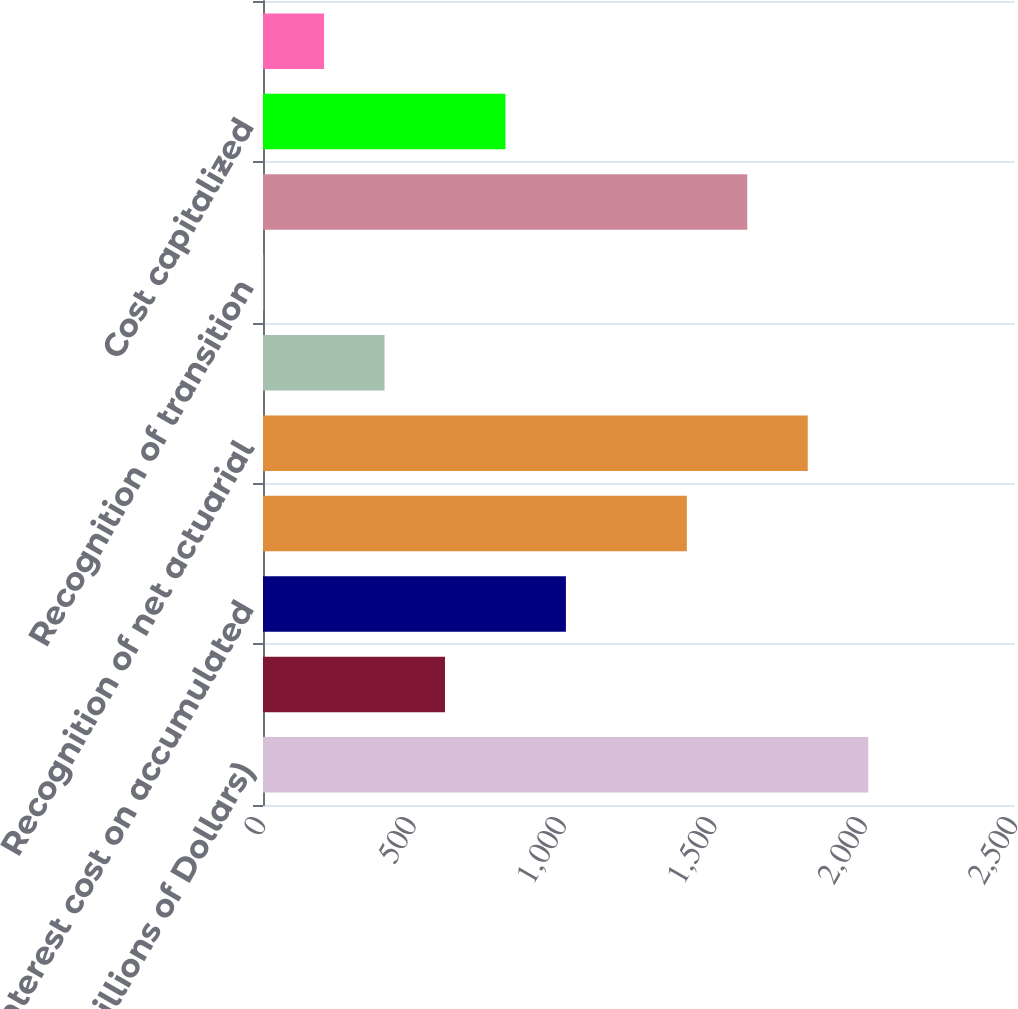<chart> <loc_0><loc_0><loc_500><loc_500><bar_chart><fcel>(Millions of Dollars)<fcel>Service cost<fcel>Interest cost on accumulated<fcel>Expected return on plan assets<fcel>Recognition of net actuarial<fcel>Recognition of prior service<fcel>Recognition of transition<fcel>NET PERIODIC POSTRETIREMENT<fcel>Cost capitalized<fcel>Reconciliation to rate level<nl><fcel>2012<fcel>605<fcel>1007<fcel>1409<fcel>1811<fcel>404<fcel>2<fcel>1610<fcel>806<fcel>203<nl></chart> 